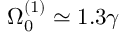<formula> <loc_0><loc_0><loc_500><loc_500>\Omega _ { 0 } ^ { ( 1 ) } \simeq 1 . 3 \gamma</formula> 